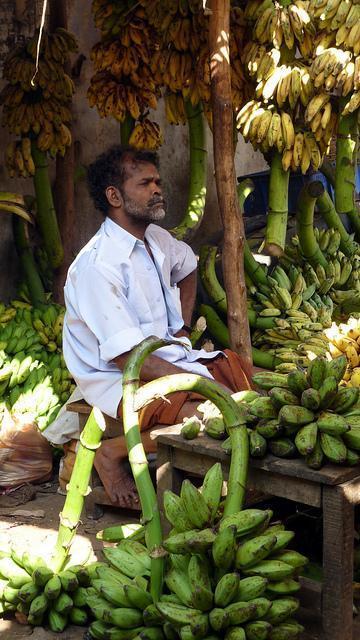How many bananas can be seen?
Give a very brief answer. 7. How many kites are in the air?
Give a very brief answer. 0. 